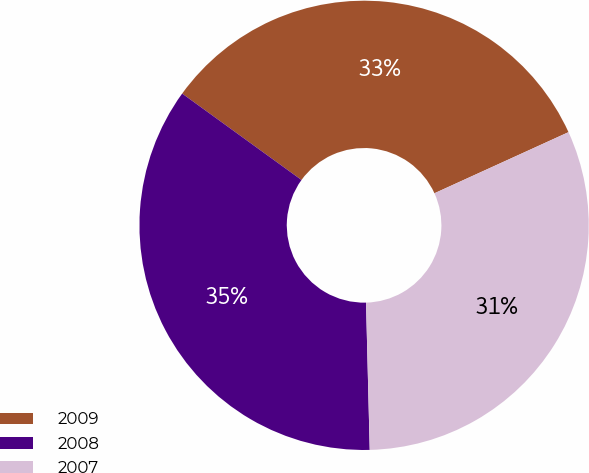<chart> <loc_0><loc_0><loc_500><loc_500><pie_chart><fcel>2009<fcel>2008<fcel>2007<nl><fcel>33.22%<fcel>35.38%<fcel>31.41%<nl></chart> 